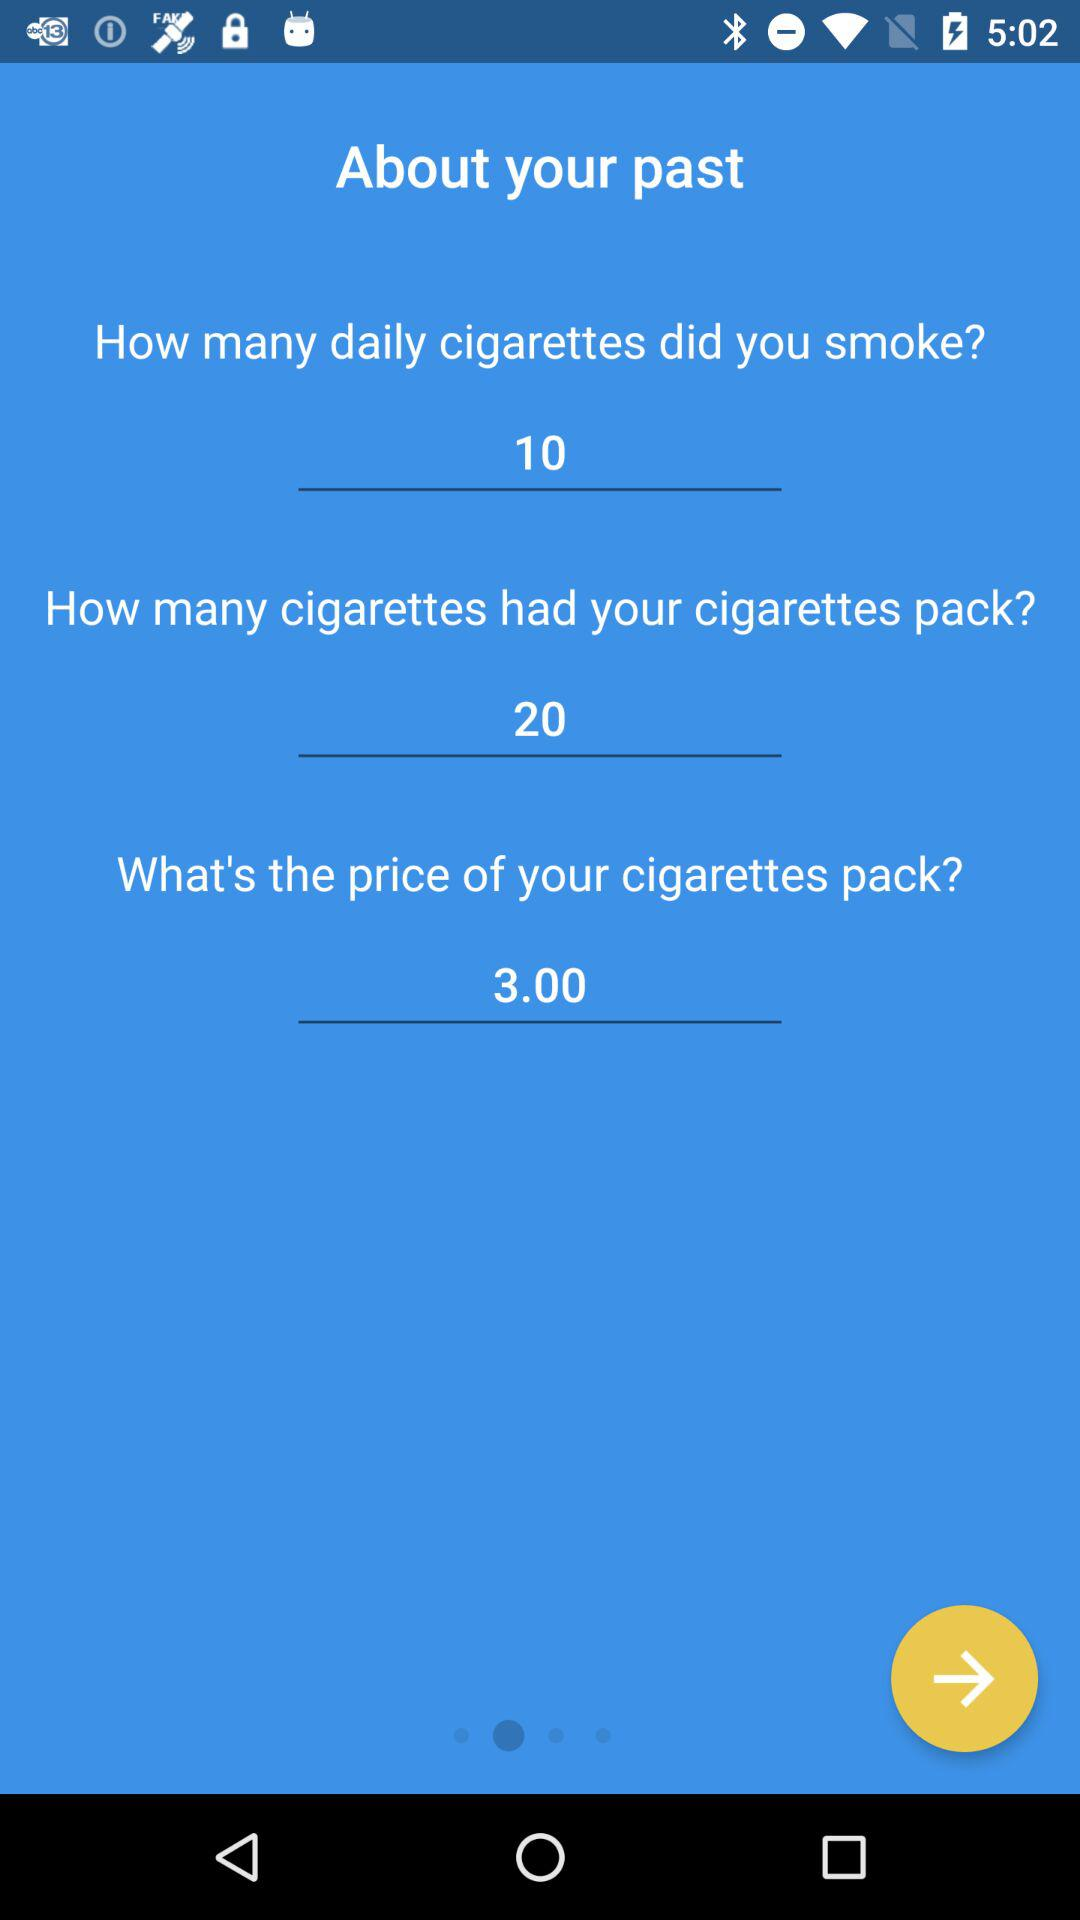What is the price of my cigarette pack? The price is 3.00. 